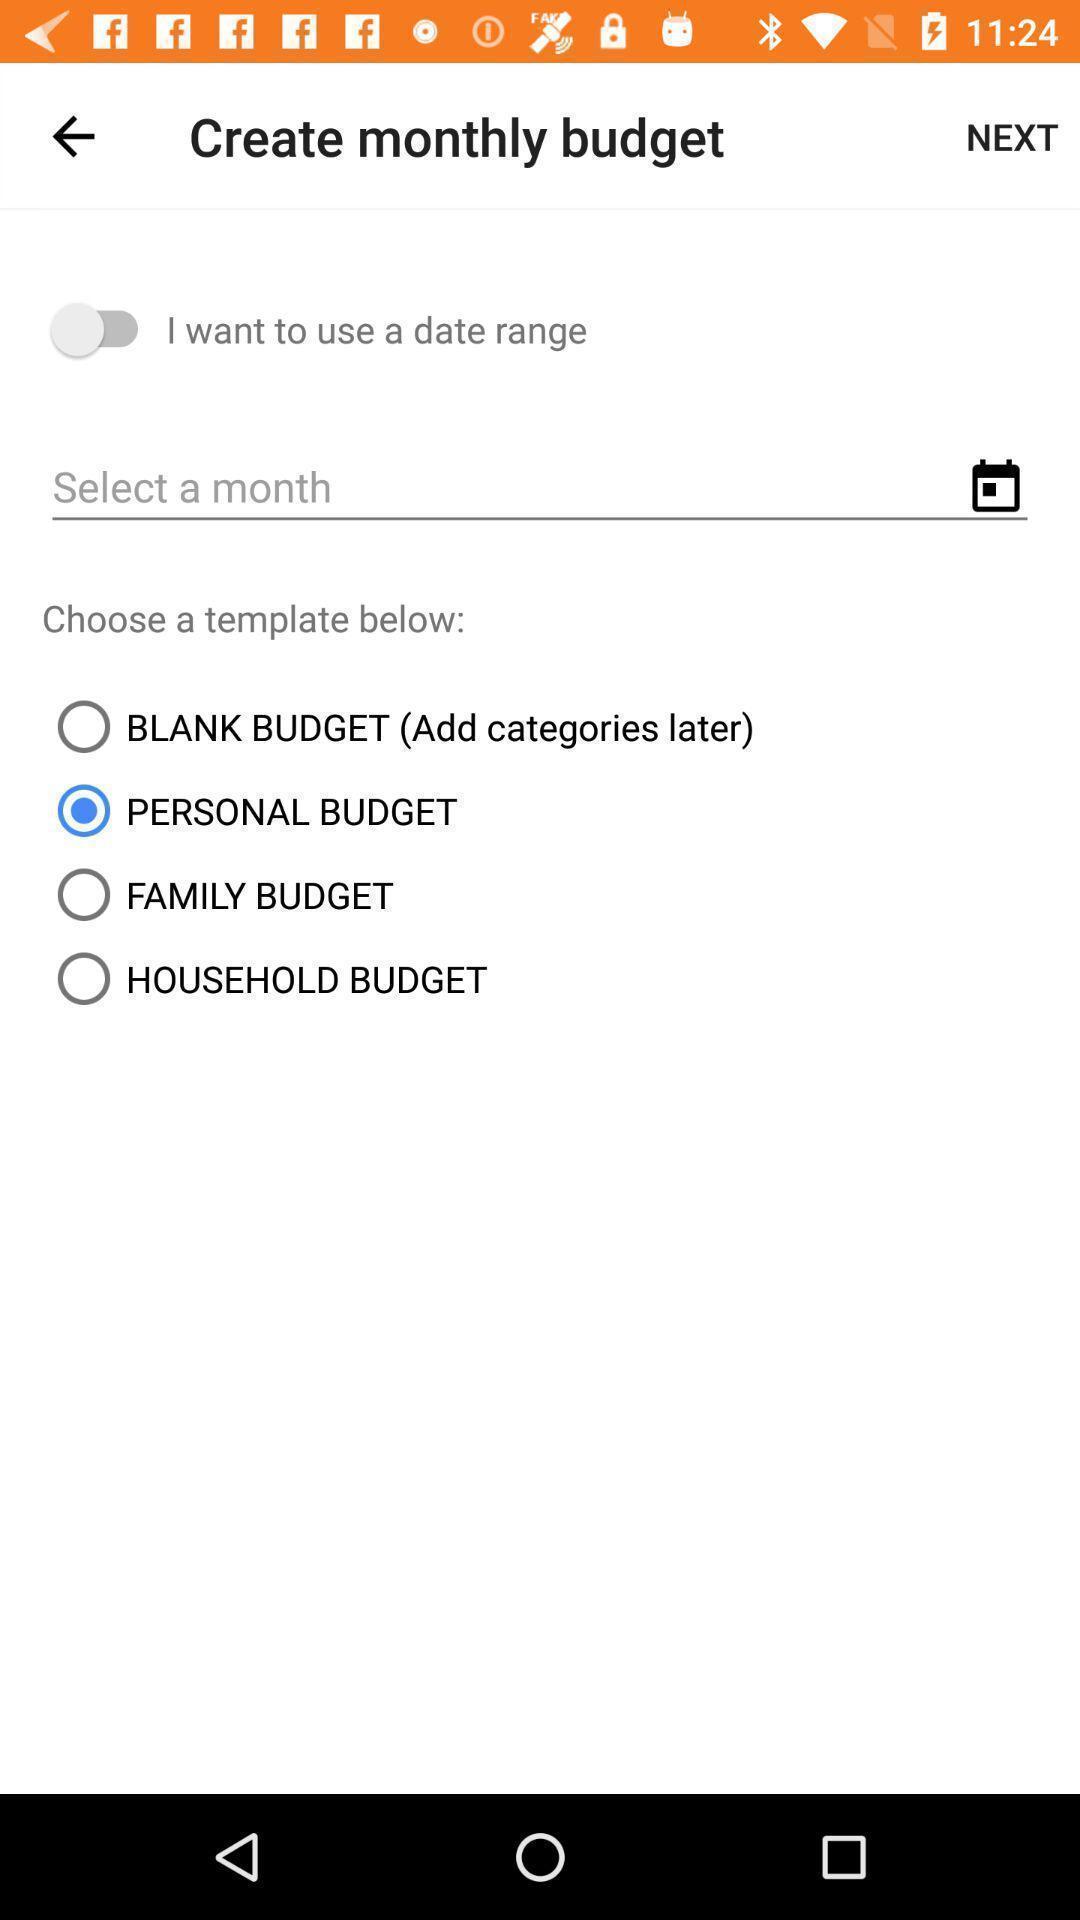Describe the content in this image. Page with options to create monthly budget. 